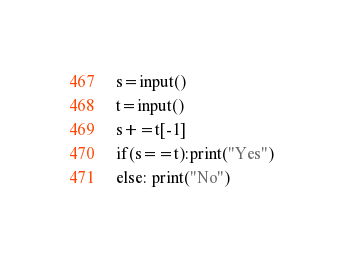<code> <loc_0><loc_0><loc_500><loc_500><_Python_>s=input()
t=input()
s+=t[-1]
if(s==t):print("Yes")
else: print("No")</code> 